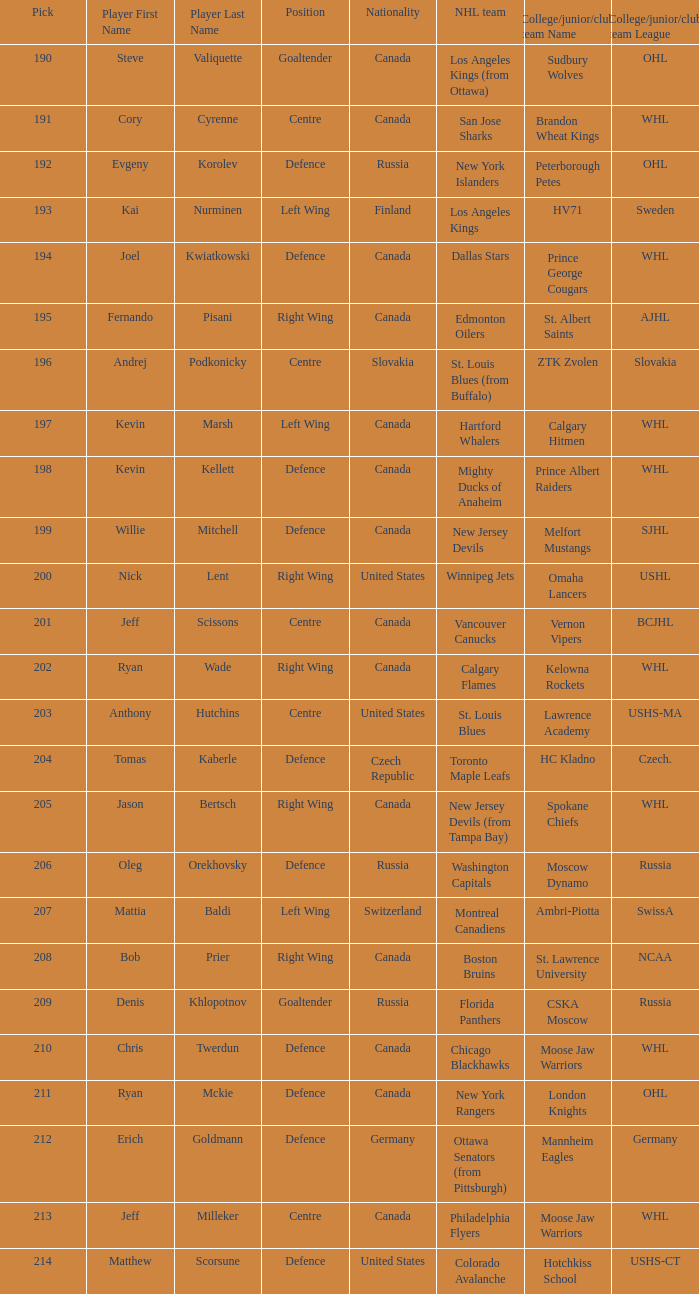Name the number of nationalities for ryan mckie 1.0. 